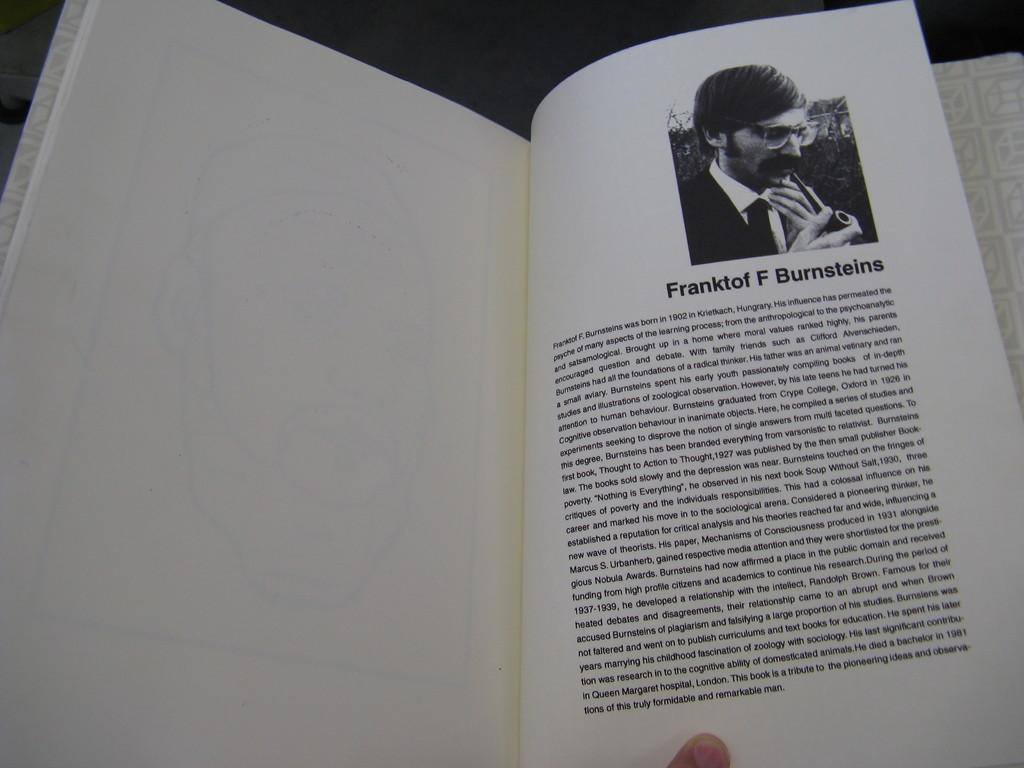<image>
Relay a brief, clear account of the picture shown. A person is reading a book with a photo of a man and the title Franktof F Burnsteins. 